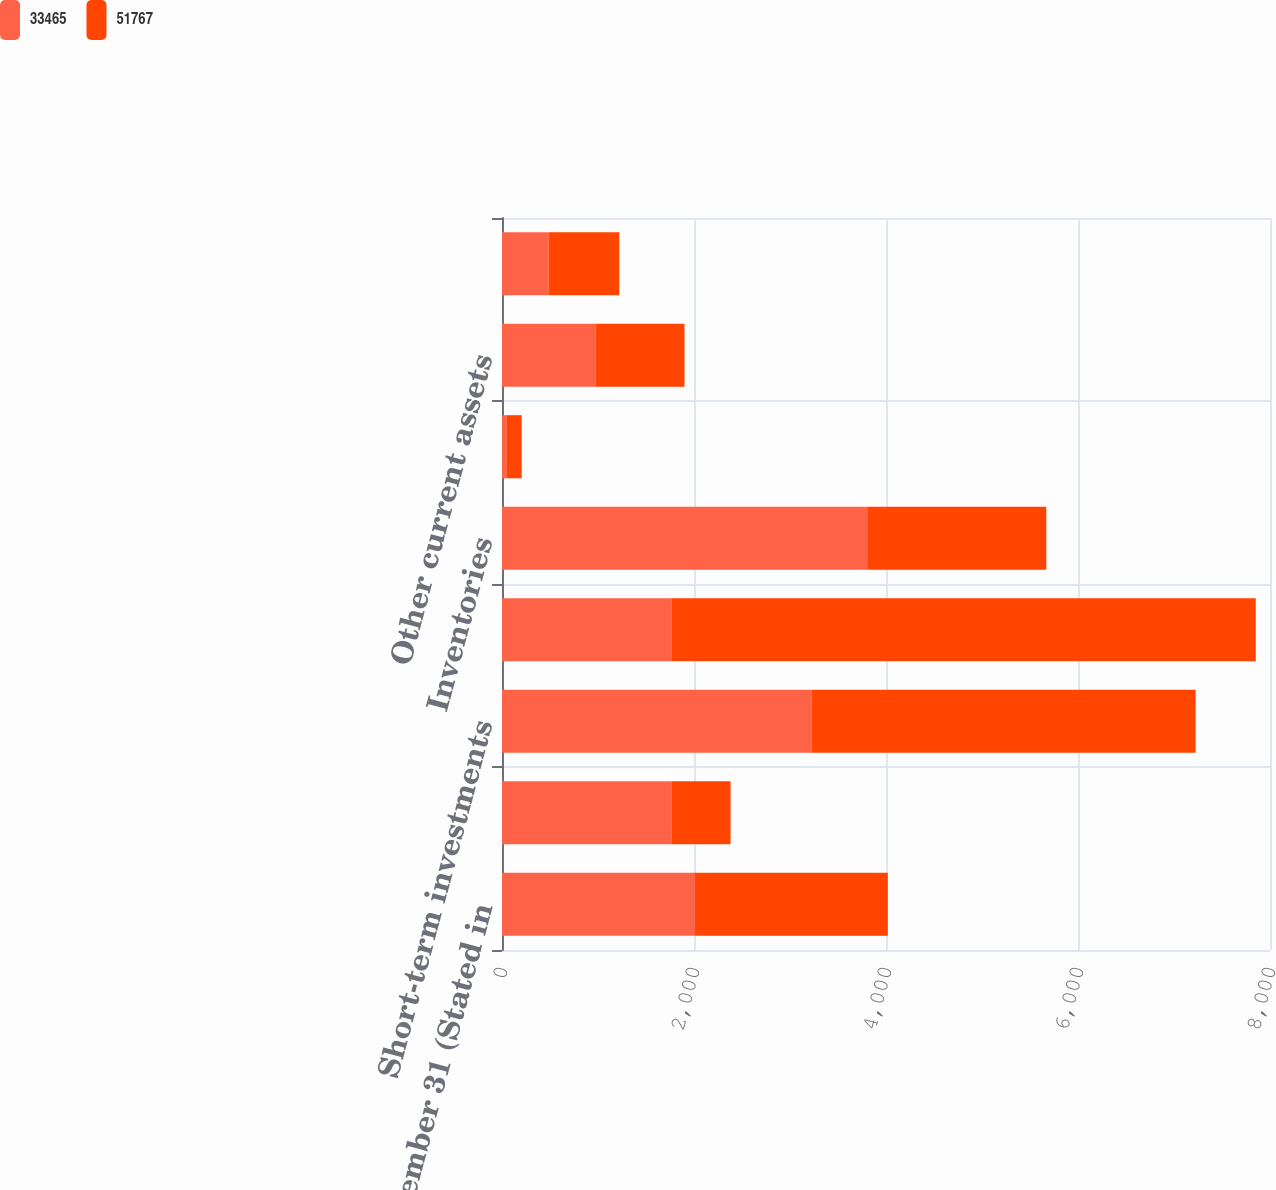Convert chart to OTSL. <chart><loc_0><loc_0><loc_500><loc_500><stacked_bar_chart><ecel><fcel>December 31 (Stated in<fcel>Cash<fcel>Short-term investments<fcel>Receivables less allowance for<fcel>Inventories<fcel>Deferred taxes<fcel>Other current assets<fcel>Fixed Income Investments held<nl><fcel>33465<fcel>2010<fcel>1764<fcel>3226<fcel>1764<fcel>3804<fcel>51<fcel>975<fcel>484<nl><fcel>51767<fcel>2009<fcel>617<fcel>3999<fcel>6088<fcel>1866<fcel>154<fcel>926<fcel>738<nl></chart> 